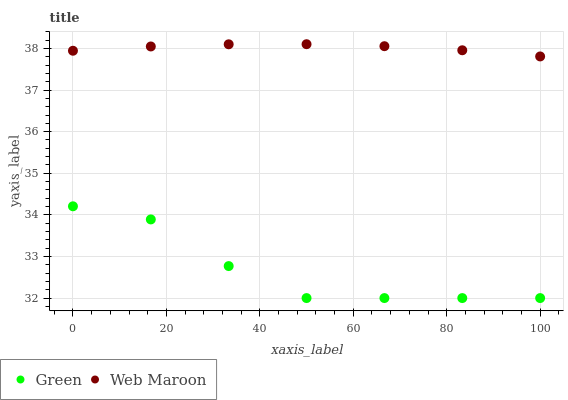Does Green have the minimum area under the curve?
Answer yes or no. Yes. Does Web Maroon have the maximum area under the curve?
Answer yes or no. Yes. Does Green have the maximum area under the curve?
Answer yes or no. No. Is Web Maroon the smoothest?
Answer yes or no. Yes. Is Green the roughest?
Answer yes or no. Yes. Is Green the smoothest?
Answer yes or no. No. Does Green have the lowest value?
Answer yes or no. Yes. Does Web Maroon have the highest value?
Answer yes or no. Yes. Does Green have the highest value?
Answer yes or no. No. Is Green less than Web Maroon?
Answer yes or no. Yes. Is Web Maroon greater than Green?
Answer yes or no. Yes. Does Green intersect Web Maroon?
Answer yes or no. No. 